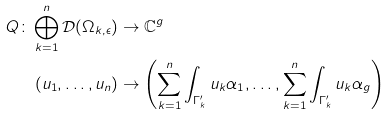<formula> <loc_0><loc_0><loc_500><loc_500>Q \colon \bigoplus _ { k = 1 } ^ { n } \mathcal { D } ( \Omega _ { k , \epsilon } ) & \rightarrow \mathbb { C } ^ { g } \\ ( u _ { 1 } , \dots , u _ { n } ) & \rightarrow \left ( \sum _ { k = 1 } ^ { n } \int _ { \Gamma _ { k } ^ { \prime } } u _ { k } \alpha _ { 1 } , \dots , \sum _ { k = 1 } ^ { n } \int _ { \Gamma _ { k } ^ { \prime } } u _ { k } \alpha _ { g } \right )</formula> 